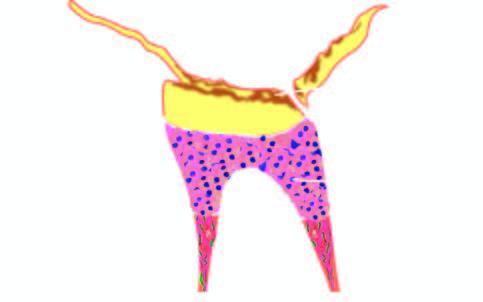s there complete destruction of enamel, deposition of secondary dentine and evidence of pulpitis?
Answer the question using a single word or phrase. Yes 